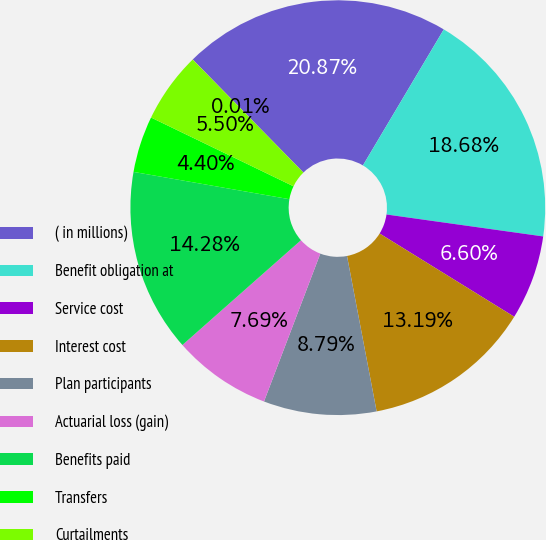Convert chart. <chart><loc_0><loc_0><loc_500><loc_500><pie_chart><fcel>( in millions)<fcel>Benefit obligation at<fcel>Service cost<fcel>Interest cost<fcel>Plan participants<fcel>Actuarial loss (gain)<fcel>Benefits paid<fcel>Transfers<fcel>Curtailments<fcel>Medicare Part D subsidy<nl><fcel>20.87%<fcel>18.68%<fcel>6.6%<fcel>13.19%<fcel>8.79%<fcel>7.69%<fcel>14.28%<fcel>4.4%<fcel>5.5%<fcel>0.01%<nl></chart> 